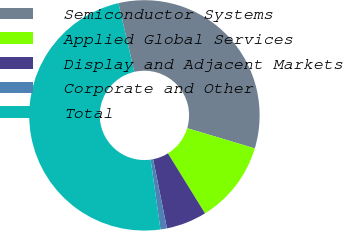Convert chart. <chart><loc_0><loc_0><loc_500><loc_500><pie_chart><fcel>Semiconductor Systems<fcel>Applied Global Services<fcel>Display and Adjacent Markets<fcel>Corporate and Other<fcel>Total<nl><fcel>33.25%<fcel>11.56%<fcel>5.68%<fcel>0.91%<fcel>48.6%<nl></chart> 